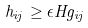<formula> <loc_0><loc_0><loc_500><loc_500>h _ { i j } \geq \epsilon H g _ { i j }</formula> 